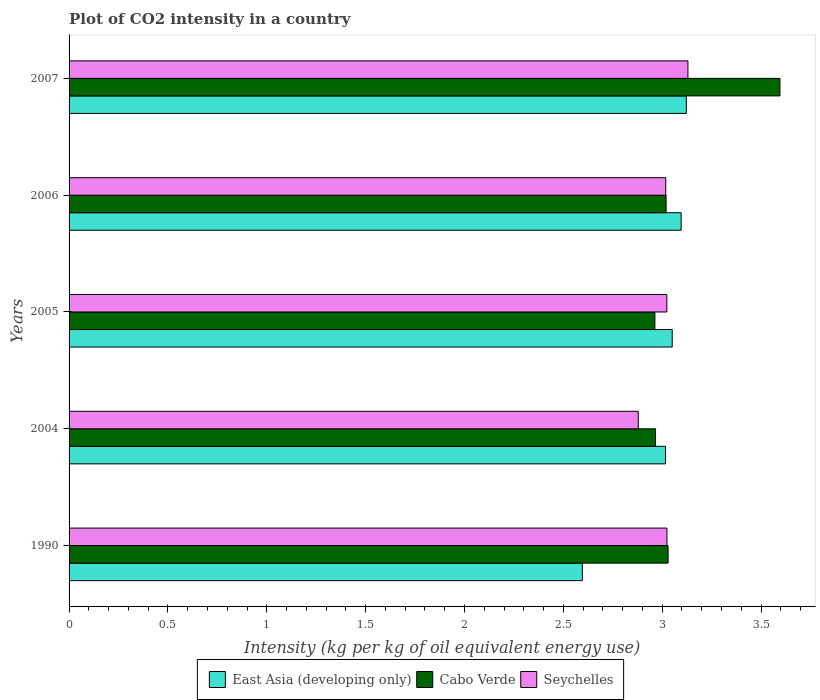How many different coloured bars are there?
Offer a terse response. 3. How many groups of bars are there?
Your answer should be compact. 5. Are the number of bars per tick equal to the number of legend labels?
Make the answer very short. Yes. Are the number of bars on each tick of the Y-axis equal?
Give a very brief answer. Yes. How many bars are there on the 4th tick from the top?
Keep it short and to the point. 3. How many bars are there on the 3rd tick from the bottom?
Your answer should be very brief. 3. What is the label of the 1st group of bars from the top?
Your response must be concise. 2007. In how many cases, is the number of bars for a given year not equal to the number of legend labels?
Your response must be concise. 0. What is the CO2 intensity in in East Asia (developing only) in 1990?
Provide a short and direct response. 2.6. Across all years, what is the maximum CO2 intensity in in Cabo Verde?
Give a very brief answer. 3.6. Across all years, what is the minimum CO2 intensity in in East Asia (developing only)?
Ensure brevity in your answer.  2.6. In which year was the CO2 intensity in in Seychelles minimum?
Make the answer very short. 2004. What is the total CO2 intensity in in East Asia (developing only) in the graph?
Offer a very short reply. 14.88. What is the difference between the CO2 intensity in in Seychelles in 2006 and that in 2007?
Offer a very short reply. -0.11. What is the difference between the CO2 intensity in in Seychelles in 1990 and the CO2 intensity in in Cabo Verde in 2006?
Provide a short and direct response. 0. What is the average CO2 intensity in in East Asia (developing only) per year?
Give a very brief answer. 2.98. In the year 2007, what is the difference between the CO2 intensity in in Cabo Verde and CO2 intensity in in East Asia (developing only)?
Provide a succinct answer. 0.47. In how many years, is the CO2 intensity in in Seychelles greater than 1.5 kg?
Make the answer very short. 5. What is the ratio of the CO2 intensity in in Cabo Verde in 2005 to that in 2006?
Give a very brief answer. 0.98. Is the CO2 intensity in in Seychelles in 1990 less than that in 2004?
Provide a succinct answer. No. Is the difference between the CO2 intensity in in Cabo Verde in 1990 and 2006 greater than the difference between the CO2 intensity in in East Asia (developing only) in 1990 and 2006?
Offer a terse response. Yes. What is the difference between the highest and the second highest CO2 intensity in in Seychelles?
Your answer should be compact. 0.11. What is the difference between the highest and the lowest CO2 intensity in in East Asia (developing only)?
Your answer should be very brief. 0.53. Is the sum of the CO2 intensity in in Cabo Verde in 2004 and 2007 greater than the maximum CO2 intensity in in East Asia (developing only) across all years?
Offer a terse response. Yes. What does the 2nd bar from the top in 2006 represents?
Keep it short and to the point. Cabo Verde. What does the 3rd bar from the bottom in 2007 represents?
Ensure brevity in your answer.  Seychelles. Is it the case that in every year, the sum of the CO2 intensity in in Seychelles and CO2 intensity in in Cabo Verde is greater than the CO2 intensity in in East Asia (developing only)?
Give a very brief answer. Yes. What is the difference between two consecutive major ticks on the X-axis?
Keep it short and to the point. 0.5. Are the values on the major ticks of X-axis written in scientific E-notation?
Your response must be concise. No. Where does the legend appear in the graph?
Provide a succinct answer. Bottom center. How many legend labels are there?
Your answer should be very brief. 3. How are the legend labels stacked?
Your answer should be compact. Horizontal. What is the title of the graph?
Provide a short and direct response. Plot of CO2 intensity in a country. What is the label or title of the X-axis?
Make the answer very short. Intensity (kg per kg of oil equivalent energy use). What is the Intensity (kg per kg of oil equivalent energy use) in East Asia (developing only) in 1990?
Ensure brevity in your answer.  2.6. What is the Intensity (kg per kg of oil equivalent energy use) of Cabo Verde in 1990?
Ensure brevity in your answer.  3.03. What is the Intensity (kg per kg of oil equivalent energy use) in Seychelles in 1990?
Your answer should be compact. 3.02. What is the Intensity (kg per kg of oil equivalent energy use) of East Asia (developing only) in 2004?
Your answer should be very brief. 3.02. What is the Intensity (kg per kg of oil equivalent energy use) of Cabo Verde in 2004?
Keep it short and to the point. 2.97. What is the Intensity (kg per kg of oil equivalent energy use) in Seychelles in 2004?
Give a very brief answer. 2.88. What is the Intensity (kg per kg of oil equivalent energy use) of East Asia (developing only) in 2005?
Provide a succinct answer. 3.05. What is the Intensity (kg per kg of oil equivalent energy use) of Cabo Verde in 2005?
Offer a terse response. 2.96. What is the Intensity (kg per kg of oil equivalent energy use) in Seychelles in 2005?
Keep it short and to the point. 3.02. What is the Intensity (kg per kg of oil equivalent energy use) in East Asia (developing only) in 2006?
Give a very brief answer. 3.1. What is the Intensity (kg per kg of oil equivalent energy use) in Cabo Verde in 2006?
Give a very brief answer. 3.02. What is the Intensity (kg per kg of oil equivalent energy use) of Seychelles in 2006?
Ensure brevity in your answer.  3.02. What is the Intensity (kg per kg of oil equivalent energy use) of East Asia (developing only) in 2007?
Offer a very short reply. 3.12. What is the Intensity (kg per kg of oil equivalent energy use) of Cabo Verde in 2007?
Offer a terse response. 3.6. What is the Intensity (kg per kg of oil equivalent energy use) in Seychelles in 2007?
Offer a very short reply. 3.13. Across all years, what is the maximum Intensity (kg per kg of oil equivalent energy use) of East Asia (developing only)?
Your answer should be very brief. 3.12. Across all years, what is the maximum Intensity (kg per kg of oil equivalent energy use) of Cabo Verde?
Keep it short and to the point. 3.6. Across all years, what is the maximum Intensity (kg per kg of oil equivalent energy use) of Seychelles?
Provide a short and direct response. 3.13. Across all years, what is the minimum Intensity (kg per kg of oil equivalent energy use) of East Asia (developing only)?
Your response must be concise. 2.6. Across all years, what is the minimum Intensity (kg per kg of oil equivalent energy use) of Cabo Verde?
Offer a very short reply. 2.96. Across all years, what is the minimum Intensity (kg per kg of oil equivalent energy use) in Seychelles?
Ensure brevity in your answer.  2.88. What is the total Intensity (kg per kg of oil equivalent energy use) of East Asia (developing only) in the graph?
Provide a short and direct response. 14.88. What is the total Intensity (kg per kg of oil equivalent energy use) of Cabo Verde in the graph?
Provide a succinct answer. 15.58. What is the total Intensity (kg per kg of oil equivalent energy use) of Seychelles in the graph?
Ensure brevity in your answer.  15.08. What is the difference between the Intensity (kg per kg of oil equivalent energy use) in East Asia (developing only) in 1990 and that in 2004?
Offer a terse response. -0.42. What is the difference between the Intensity (kg per kg of oil equivalent energy use) in Cabo Verde in 1990 and that in 2004?
Provide a succinct answer. 0.06. What is the difference between the Intensity (kg per kg of oil equivalent energy use) in Seychelles in 1990 and that in 2004?
Keep it short and to the point. 0.14. What is the difference between the Intensity (kg per kg of oil equivalent energy use) of East Asia (developing only) in 1990 and that in 2005?
Provide a succinct answer. -0.45. What is the difference between the Intensity (kg per kg of oil equivalent energy use) in Cabo Verde in 1990 and that in 2005?
Offer a terse response. 0.07. What is the difference between the Intensity (kg per kg of oil equivalent energy use) in East Asia (developing only) in 1990 and that in 2006?
Provide a succinct answer. -0.5. What is the difference between the Intensity (kg per kg of oil equivalent energy use) of Cabo Verde in 1990 and that in 2006?
Offer a terse response. 0.01. What is the difference between the Intensity (kg per kg of oil equivalent energy use) of Seychelles in 1990 and that in 2006?
Make the answer very short. 0.01. What is the difference between the Intensity (kg per kg of oil equivalent energy use) of East Asia (developing only) in 1990 and that in 2007?
Your response must be concise. -0.53. What is the difference between the Intensity (kg per kg of oil equivalent energy use) of Cabo Verde in 1990 and that in 2007?
Your response must be concise. -0.57. What is the difference between the Intensity (kg per kg of oil equivalent energy use) in Seychelles in 1990 and that in 2007?
Your response must be concise. -0.11. What is the difference between the Intensity (kg per kg of oil equivalent energy use) of East Asia (developing only) in 2004 and that in 2005?
Give a very brief answer. -0.03. What is the difference between the Intensity (kg per kg of oil equivalent energy use) in Cabo Verde in 2004 and that in 2005?
Keep it short and to the point. 0. What is the difference between the Intensity (kg per kg of oil equivalent energy use) of Seychelles in 2004 and that in 2005?
Provide a short and direct response. -0.14. What is the difference between the Intensity (kg per kg of oil equivalent energy use) in East Asia (developing only) in 2004 and that in 2006?
Give a very brief answer. -0.08. What is the difference between the Intensity (kg per kg of oil equivalent energy use) in Cabo Verde in 2004 and that in 2006?
Your answer should be very brief. -0.05. What is the difference between the Intensity (kg per kg of oil equivalent energy use) of Seychelles in 2004 and that in 2006?
Keep it short and to the point. -0.14. What is the difference between the Intensity (kg per kg of oil equivalent energy use) in East Asia (developing only) in 2004 and that in 2007?
Your response must be concise. -0.11. What is the difference between the Intensity (kg per kg of oil equivalent energy use) in Cabo Verde in 2004 and that in 2007?
Keep it short and to the point. -0.63. What is the difference between the Intensity (kg per kg of oil equivalent energy use) in Seychelles in 2004 and that in 2007?
Your response must be concise. -0.25. What is the difference between the Intensity (kg per kg of oil equivalent energy use) in East Asia (developing only) in 2005 and that in 2006?
Provide a succinct answer. -0.05. What is the difference between the Intensity (kg per kg of oil equivalent energy use) in Cabo Verde in 2005 and that in 2006?
Provide a succinct answer. -0.06. What is the difference between the Intensity (kg per kg of oil equivalent energy use) of Seychelles in 2005 and that in 2006?
Make the answer very short. 0.01. What is the difference between the Intensity (kg per kg of oil equivalent energy use) in East Asia (developing only) in 2005 and that in 2007?
Your response must be concise. -0.07. What is the difference between the Intensity (kg per kg of oil equivalent energy use) in Cabo Verde in 2005 and that in 2007?
Your response must be concise. -0.63. What is the difference between the Intensity (kg per kg of oil equivalent energy use) in Seychelles in 2005 and that in 2007?
Provide a short and direct response. -0.11. What is the difference between the Intensity (kg per kg of oil equivalent energy use) of East Asia (developing only) in 2006 and that in 2007?
Offer a terse response. -0.03. What is the difference between the Intensity (kg per kg of oil equivalent energy use) in Cabo Verde in 2006 and that in 2007?
Your answer should be compact. -0.58. What is the difference between the Intensity (kg per kg of oil equivalent energy use) in Seychelles in 2006 and that in 2007?
Provide a succinct answer. -0.11. What is the difference between the Intensity (kg per kg of oil equivalent energy use) of East Asia (developing only) in 1990 and the Intensity (kg per kg of oil equivalent energy use) of Cabo Verde in 2004?
Provide a short and direct response. -0.37. What is the difference between the Intensity (kg per kg of oil equivalent energy use) of East Asia (developing only) in 1990 and the Intensity (kg per kg of oil equivalent energy use) of Seychelles in 2004?
Your response must be concise. -0.28. What is the difference between the Intensity (kg per kg of oil equivalent energy use) of Cabo Verde in 1990 and the Intensity (kg per kg of oil equivalent energy use) of Seychelles in 2004?
Offer a terse response. 0.15. What is the difference between the Intensity (kg per kg of oil equivalent energy use) of East Asia (developing only) in 1990 and the Intensity (kg per kg of oil equivalent energy use) of Cabo Verde in 2005?
Keep it short and to the point. -0.37. What is the difference between the Intensity (kg per kg of oil equivalent energy use) of East Asia (developing only) in 1990 and the Intensity (kg per kg of oil equivalent energy use) of Seychelles in 2005?
Offer a very short reply. -0.43. What is the difference between the Intensity (kg per kg of oil equivalent energy use) in Cabo Verde in 1990 and the Intensity (kg per kg of oil equivalent energy use) in Seychelles in 2005?
Keep it short and to the point. 0.01. What is the difference between the Intensity (kg per kg of oil equivalent energy use) in East Asia (developing only) in 1990 and the Intensity (kg per kg of oil equivalent energy use) in Cabo Verde in 2006?
Ensure brevity in your answer.  -0.42. What is the difference between the Intensity (kg per kg of oil equivalent energy use) in East Asia (developing only) in 1990 and the Intensity (kg per kg of oil equivalent energy use) in Seychelles in 2006?
Keep it short and to the point. -0.42. What is the difference between the Intensity (kg per kg of oil equivalent energy use) of Cabo Verde in 1990 and the Intensity (kg per kg of oil equivalent energy use) of Seychelles in 2006?
Offer a very short reply. 0.01. What is the difference between the Intensity (kg per kg of oil equivalent energy use) of East Asia (developing only) in 1990 and the Intensity (kg per kg of oil equivalent energy use) of Cabo Verde in 2007?
Make the answer very short. -1. What is the difference between the Intensity (kg per kg of oil equivalent energy use) in East Asia (developing only) in 1990 and the Intensity (kg per kg of oil equivalent energy use) in Seychelles in 2007?
Keep it short and to the point. -0.53. What is the difference between the Intensity (kg per kg of oil equivalent energy use) of Cabo Verde in 1990 and the Intensity (kg per kg of oil equivalent energy use) of Seychelles in 2007?
Provide a short and direct response. -0.1. What is the difference between the Intensity (kg per kg of oil equivalent energy use) of East Asia (developing only) in 2004 and the Intensity (kg per kg of oil equivalent energy use) of Cabo Verde in 2005?
Provide a succinct answer. 0.05. What is the difference between the Intensity (kg per kg of oil equivalent energy use) in East Asia (developing only) in 2004 and the Intensity (kg per kg of oil equivalent energy use) in Seychelles in 2005?
Provide a succinct answer. -0.01. What is the difference between the Intensity (kg per kg of oil equivalent energy use) of Cabo Verde in 2004 and the Intensity (kg per kg of oil equivalent energy use) of Seychelles in 2005?
Give a very brief answer. -0.06. What is the difference between the Intensity (kg per kg of oil equivalent energy use) in East Asia (developing only) in 2004 and the Intensity (kg per kg of oil equivalent energy use) in Cabo Verde in 2006?
Offer a terse response. -0. What is the difference between the Intensity (kg per kg of oil equivalent energy use) of East Asia (developing only) in 2004 and the Intensity (kg per kg of oil equivalent energy use) of Seychelles in 2006?
Give a very brief answer. -0. What is the difference between the Intensity (kg per kg of oil equivalent energy use) in Cabo Verde in 2004 and the Intensity (kg per kg of oil equivalent energy use) in Seychelles in 2006?
Make the answer very short. -0.05. What is the difference between the Intensity (kg per kg of oil equivalent energy use) of East Asia (developing only) in 2004 and the Intensity (kg per kg of oil equivalent energy use) of Cabo Verde in 2007?
Ensure brevity in your answer.  -0.58. What is the difference between the Intensity (kg per kg of oil equivalent energy use) of East Asia (developing only) in 2004 and the Intensity (kg per kg of oil equivalent energy use) of Seychelles in 2007?
Make the answer very short. -0.11. What is the difference between the Intensity (kg per kg of oil equivalent energy use) in Cabo Verde in 2004 and the Intensity (kg per kg of oil equivalent energy use) in Seychelles in 2007?
Ensure brevity in your answer.  -0.16. What is the difference between the Intensity (kg per kg of oil equivalent energy use) of East Asia (developing only) in 2005 and the Intensity (kg per kg of oil equivalent energy use) of Cabo Verde in 2006?
Your response must be concise. 0.03. What is the difference between the Intensity (kg per kg of oil equivalent energy use) in East Asia (developing only) in 2005 and the Intensity (kg per kg of oil equivalent energy use) in Seychelles in 2006?
Provide a succinct answer. 0.03. What is the difference between the Intensity (kg per kg of oil equivalent energy use) of Cabo Verde in 2005 and the Intensity (kg per kg of oil equivalent energy use) of Seychelles in 2006?
Make the answer very short. -0.05. What is the difference between the Intensity (kg per kg of oil equivalent energy use) of East Asia (developing only) in 2005 and the Intensity (kg per kg of oil equivalent energy use) of Cabo Verde in 2007?
Offer a very short reply. -0.54. What is the difference between the Intensity (kg per kg of oil equivalent energy use) of East Asia (developing only) in 2005 and the Intensity (kg per kg of oil equivalent energy use) of Seychelles in 2007?
Your answer should be compact. -0.08. What is the difference between the Intensity (kg per kg of oil equivalent energy use) of Cabo Verde in 2005 and the Intensity (kg per kg of oil equivalent energy use) of Seychelles in 2007?
Your answer should be compact. -0.17. What is the difference between the Intensity (kg per kg of oil equivalent energy use) of East Asia (developing only) in 2006 and the Intensity (kg per kg of oil equivalent energy use) of Cabo Verde in 2007?
Provide a succinct answer. -0.5. What is the difference between the Intensity (kg per kg of oil equivalent energy use) in East Asia (developing only) in 2006 and the Intensity (kg per kg of oil equivalent energy use) in Seychelles in 2007?
Provide a short and direct response. -0.03. What is the difference between the Intensity (kg per kg of oil equivalent energy use) of Cabo Verde in 2006 and the Intensity (kg per kg of oil equivalent energy use) of Seychelles in 2007?
Keep it short and to the point. -0.11. What is the average Intensity (kg per kg of oil equivalent energy use) in East Asia (developing only) per year?
Offer a very short reply. 2.98. What is the average Intensity (kg per kg of oil equivalent energy use) of Cabo Verde per year?
Your response must be concise. 3.12. What is the average Intensity (kg per kg of oil equivalent energy use) in Seychelles per year?
Provide a short and direct response. 3.02. In the year 1990, what is the difference between the Intensity (kg per kg of oil equivalent energy use) in East Asia (developing only) and Intensity (kg per kg of oil equivalent energy use) in Cabo Verde?
Offer a terse response. -0.43. In the year 1990, what is the difference between the Intensity (kg per kg of oil equivalent energy use) in East Asia (developing only) and Intensity (kg per kg of oil equivalent energy use) in Seychelles?
Your answer should be very brief. -0.43. In the year 1990, what is the difference between the Intensity (kg per kg of oil equivalent energy use) of Cabo Verde and Intensity (kg per kg of oil equivalent energy use) of Seychelles?
Offer a terse response. 0.01. In the year 2004, what is the difference between the Intensity (kg per kg of oil equivalent energy use) of East Asia (developing only) and Intensity (kg per kg of oil equivalent energy use) of Cabo Verde?
Provide a succinct answer. 0.05. In the year 2004, what is the difference between the Intensity (kg per kg of oil equivalent energy use) of East Asia (developing only) and Intensity (kg per kg of oil equivalent energy use) of Seychelles?
Give a very brief answer. 0.14. In the year 2004, what is the difference between the Intensity (kg per kg of oil equivalent energy use) of Cabo Verde and Intensity (kg per kg of oil equivalent energy use) of Seychelles?
Offer a terse response. 0.09. In the year 2005, what is the difference between the Intensity (kg per kg of oil equivalent energy use) of East Asia (developing only) and Intensity (kg per kg of oil equivalent energy use) of Cabo Verde?
Ensure brevity in your answer.  0.09. In the year 2005, what is the difference between the Intensity (kg per kg of oil equivalent energy use) of East Asia (developing only) and Intensity (kg per kg of oil equivalent energy use) of Seychelles?
Provide a short and direct response. 0.03. In the year 2005, what is the difference between the Intensity (kg per kg of oil equivalent energy use) of Cabo Verde and Intensity (kg per kg of oil equivalent energy use) of Seychelles?
Your answer should be compact. -0.06. In the year 2006, what is the difference between the Intensity (kg per kg of oil equivalent energy use) of East Asia (developing only) and Intensity (kg per kg of oil equivalent energy use) of Cabo Verde?
Keep it short and to the point. 0.08. In the year 2006, what is the difference between the Intensity (kg per kg of oil equivalent energy use) in East Asia (developing only) and Intensity (kg per kg of oil equivalent energy use) in Seychelles?
Offer a terse response. 0.08. In the year 2006, what is the difference between the Intensity (kg per kg of oil equivalent energy use) of Cabo Verde and Intensity (kg per kg of oil equivalent energy use) of Seychelles?
Keep it short and to the point. 0. In the year 2007, what is the difference between the Intensity (kg per kg of oil equivalent energy use) of East Asia (developing only) and Intensity (kg per kg of oil equivalent energy use) of Cabo Verde?
Your answer should be very brief. -0.47. In the year 2007, what is the difference between the Intensity (kg per kg of oil equivalent energy use) in East Asia (developing only) and Intensity (kg per kg of oil equivalent energy use) in Seychelles?
Keep it short and to the point. -0.01. In the year 2007, what is the difference between the Intensity (kg per kg of oil equivalent energy use) in Cabo Verde and Intensity (kg per kg of oil equivalent energy use) in Seychelles?
Offer a very short reply. 0.47. What is the ratio of the Intensity (kg per kg of oil equivalent energy use) in East Asia (developing only) in 1990 to that in 2004?
Keep it short and to the point. 0.86. What is the ratio of the Intensity (kg per kg of oil equivalent energy use) in Cabo Verde in 1990 to that in 2004?
Your answer should be very brief. 1.02. What is the ratio of the Intensity (kg per kg of oil equivalent energy use) in Seychelles in 1990 to that in 2004?
Provide a succinct answer. 1.05. What is the ratio of the Intensity (kg per kg of oil equivalent energy use) of East Asia (developing only) in 1990 to that in 2005?
Make the answer very short. 0.85. What is the ratio of the Intensity (kg per kg of oil equivalent energy use) of Cabo Verde in 1990 to that in 2005?
Keep it short and to the point. 1.02. What is the ratio of the Intensity (kg per kg of oil equivalent energy use) of East Asia (developing only) in 1990 to that in 2006?
Your answer should be compact. 0.84. What is the ratio of the Intensity (kg per kg of oil equivalent energy use) of Cabo Verde in 1990 to that in 2006?
Ensure brevity in your answer.  1. What is the ratio of the Intensity (kg per kg of oil equivalent energy use) of Seychelles in 1990 to that in 2006?
Keep it short and to the point. 1. What is the ratio of the Intensity (kg per kg of oil equivalent energy use) of East Asia (developing only) in 1990 to that in 2007?
Give a very brief answer. 0.83. What is the ratio of the Intensity (kg per kg of oil equivalent energy use) of Cabo Verde in 1990 to that in 2007?
Your answer should be compact. 0.84. What is the ratio of the Intensity (kg per kg of oil equivalent energy use) in Seychelles in 1990 to that in 2007?
Provide a short and direct response. 0.97. What is the ratio of the Intensity (kg per kg of oil equivalent energy use) in Seychelles in 2004 to that in 2005?
Make the answer very short. 0.95. What is the ratio of the Intensity (kg per kg of oil equivalent energy use) of East Asia (developing only) in 2004 to that in 2006?
Offer a very short reply. 0.97. What is the ratio of the Intensity (kg per kg of oil equivalent energy use) of Cabo Verde in 2004 to that in 2006?
Provide a short and direct response. 0.98. What is the ratio of the Intensity (kg per kg of oil equivalent energy use) in Seychelles in 2004 to that in 2006?
Keep it short and to the point. 0.95. What is the ratio of the Intensity (kg per kg of oil equivalent energy use) of East Asia (developing only) in 2004 to that in 2007?
Your response must be concise. 0.97. What is the ratio of the Intensity (kg per kg of oil equivalent energy use) in Cabo Verde in 2004 to that in 2007?
Ensure brevity in your answer.  0.82. What is the ratio of the Intensity (kg per kg of oil equivalent energy use) in Seychelles in 2004 to that in 2007?
Your answer should be very brief. 0.92. What is the ratio of the Intensity (kg per kg of oil equivalent energy use) in East Asia (developing only) in 2005 to that in 2006?
Provide a succinct answer. 0.99. What is the ratio of the Intensity (kg per kg of oil equivalent energy use) of Cabo Verde in 2005 to that in 2006?
Provide a short and direct response. 0.98. What is the ratio of the Intensity (kg per kg of oil equivalent energy use) of East Asia (developing only) in 2005 to that in 2007?
Give a very brief answer. 0.98. What is the ratio of the Intensity (kg per kg of oil equivalent energy use) in Cabo Verde in 2005 to that in 2007?
Offer a terse response. 0.82. What is the ratio of the Intensity (kg per kg of oil equivalent energy use) in Seychelles in 2005 to that in 2007?
Give a very brief answer. 0.97. What is the ratio of the Intensity (kg per kg of oil equivalent energy use) of Cabo Verde in 2006 to that in 2007?
Make the answer very short. 0.84. What is the ratio of the Intensity (kg per kg of oil equivalent energy use) in Seychelles in 2006 to that in 2007?
Your answer should be compact. 0.96. What is the difference between the highest and the second highest Intensity (kg per kg of oil equivalent energy use) of East Asia (developing only)?
Give a very brief answer. 0.03. What is the difference between the highest and the second highest Intensity (kg per kg of oil equivalent energy use) in Cabo Verde?
Make the answer very short. 0.57. What is the difference between the highest and the second highest Intensity (kg per kg of oil equivalent energy use) in Seychelles?
Provide a succinct answer. 0.11. What is the difference between the highest and the lowest Intensity (kg per kg of oil equivalent energy use) of East Asia (developing only)?
Offer a terse response. 0.53. What is the difference between the highest and the lowest Intensity (kg per kg of oil equivalent energy use) in Cabo Verde?
Keep it short and to the point. 0.63. What is the difference between the highest and the lowest Intensity (kg per kg of oil equivalent energy use) of Seychelles?
Provide a succinct answer. 0.25. 